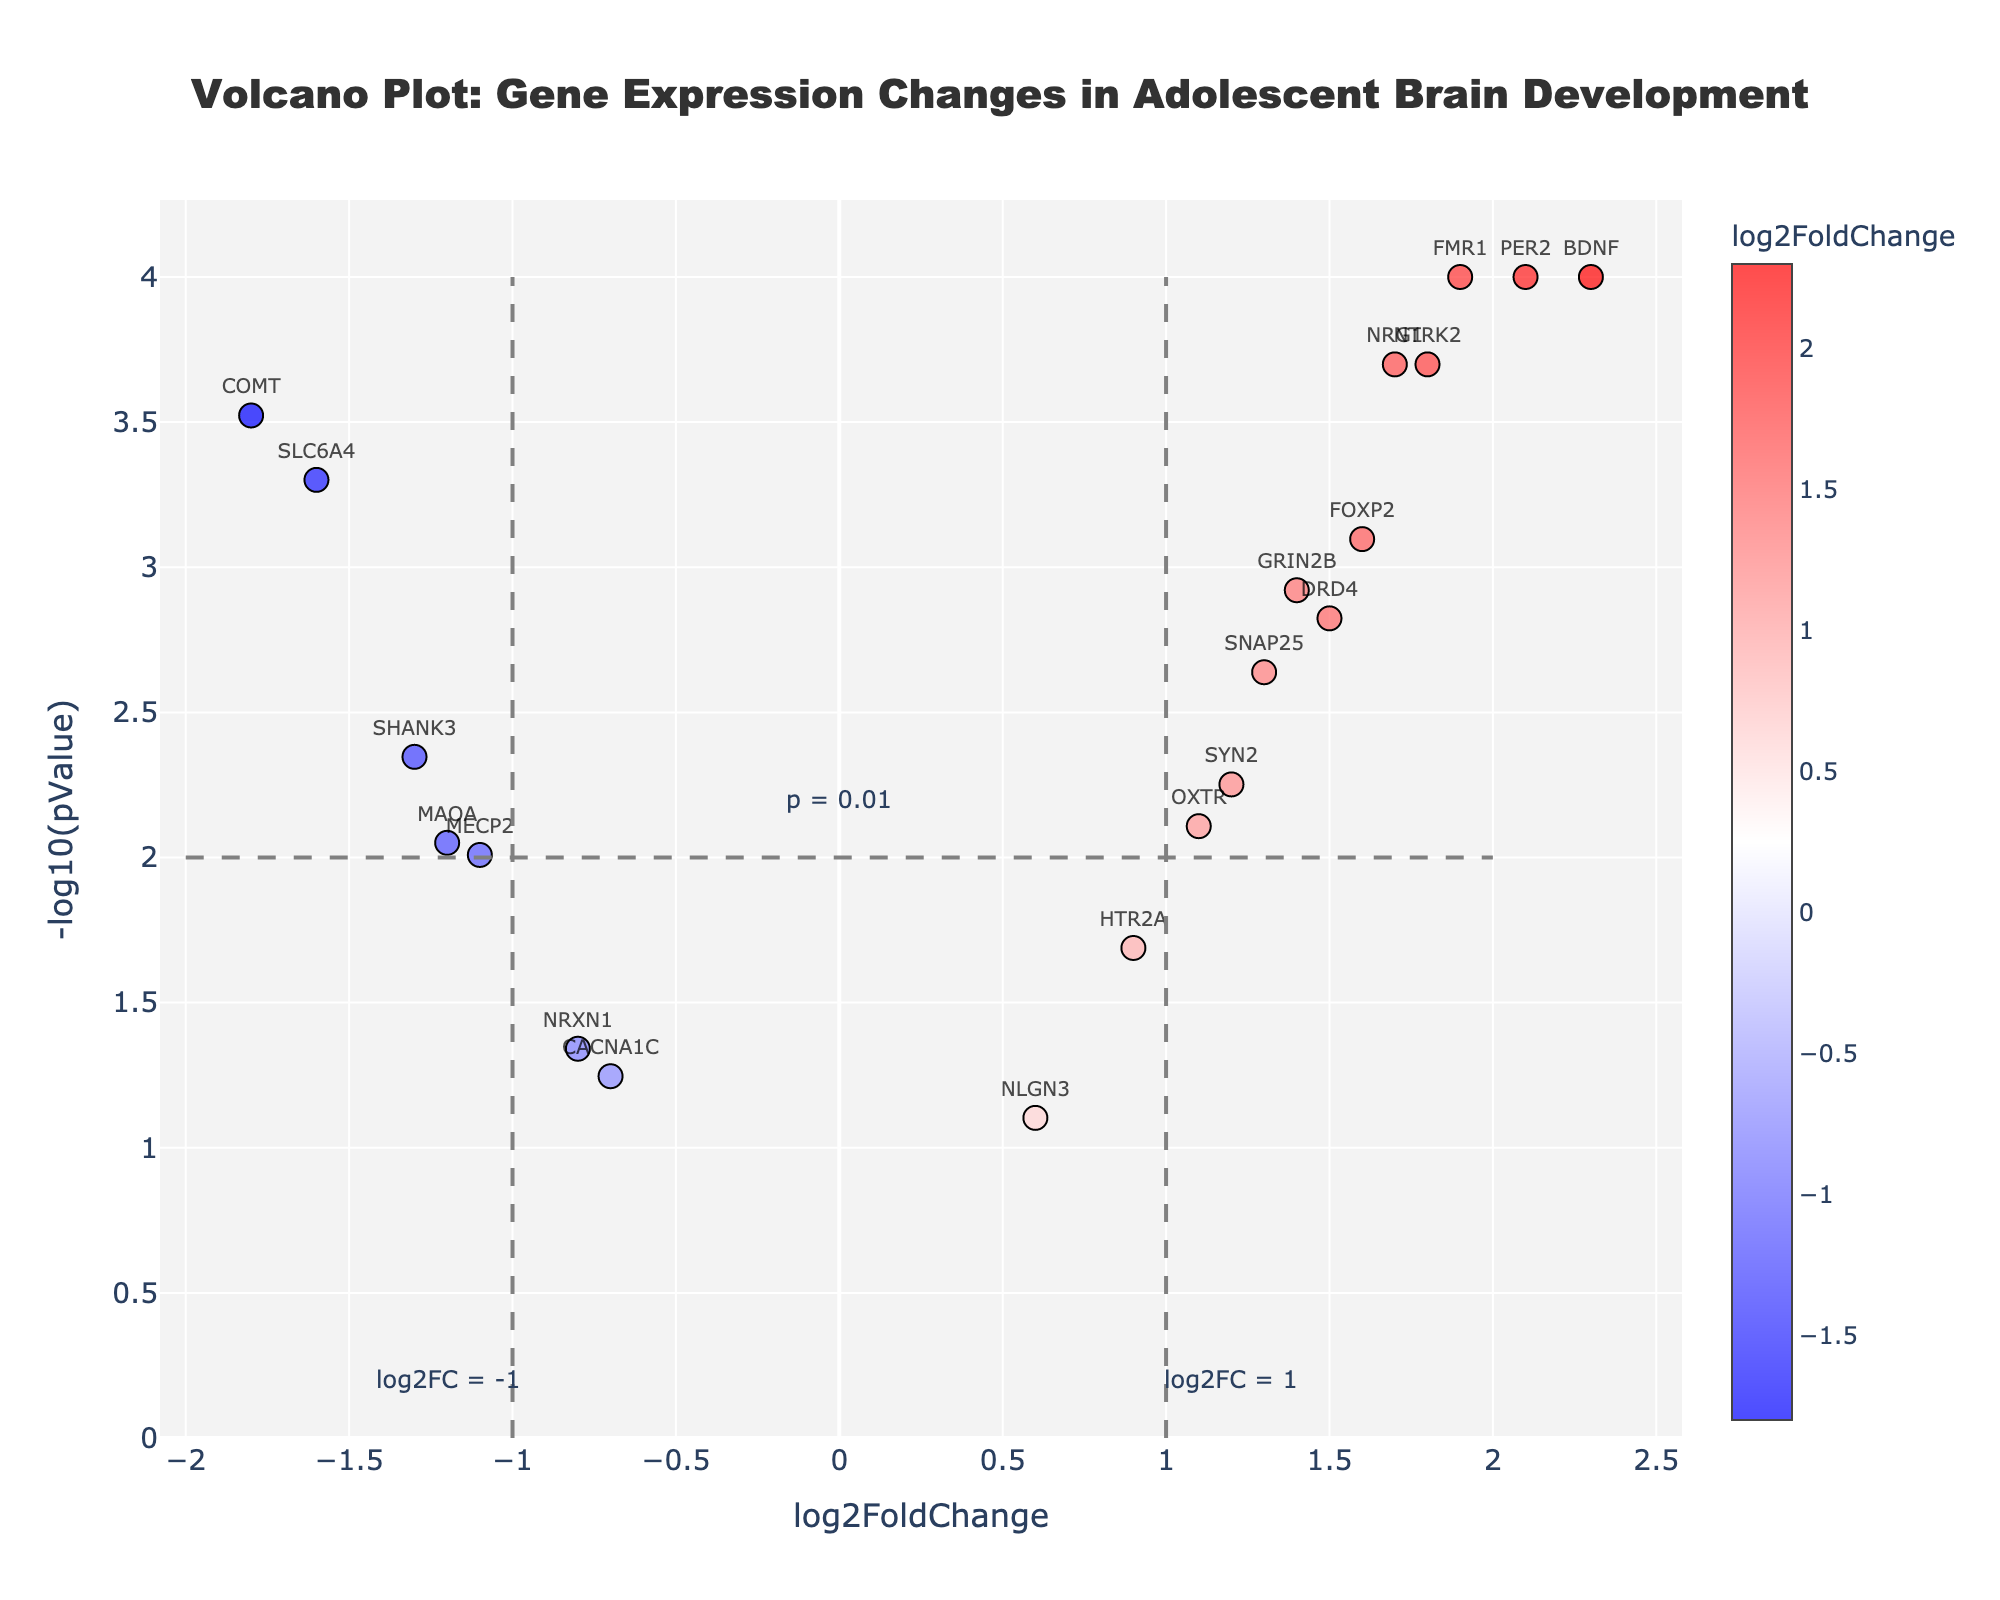what is the title of the plot? The title is provided at the top center of the figure which reads, "Volcano Plot: Gene Expression Changes in Adolescent Brain Development".
Answer: Volcano Plot: Gene Expression Changes in Adolescent Brain Development how many data points are there in the plot? Each gene represents a single data point. By counting the number of genes listed, we find there are 20 data points.
Answer: 20 what is the significance threshold for p-values? There is an annotation at y = 2.2 that indicates the significance threshold, "p = 0.01". This means any point above this line has a p-value less than 0.01.
Answer: p = 0.01 which gene has the highest log2FoldChange? By locating the point farthest to the right on the x-axis, we find the gene with the highest log2FoldChange is BDNF at 2.3.
Answer: BDNF which gene has the lowest p-value? The y-axis is scaled as -log10(pValue), so the highest point on the y-axis indicates the lowest p-value. The gene with the highest position is BDNF, PER2, and FMR1 all at -log10(pValue) around 4.
Answer: BDNF, PER2, FMR1 which genes have a log2FoldChange greater than 2? By identifying the points farther right than the x = 2 threshold, the genes are BDNF (2.3) and PER2 (2.1).
Answer: BDNF, PER2 which gene has the smallest log2FoldChange? The point farthest to the left on the x-axis indicates the smallest log2FoldChange, which is COMT at -1.8.
Answer: COMT how many genes have a log2FoldChange between -1 and 1? To find this, count the number of genes that fall between x = -1 and x = 1. Counting these, there are DRD4, HTR2A, NRXN1, CACNA1C, and NLGN3, so 5 genes in total.
Answer: 5 which genes are significantly upregulated (log2FoldChange > 1 and p < 0.01)? To identify this, we look for points to the right of x = 1 and above y = 2. These are BDNF, PER2, FMR1, NTRK2, and FOXP2.
Answer: BDNF, PER2, FMR1, NTRK2, FOXP2 which genes show significant downregulation (log2FoldChange < -1 and p < 0.01)? To find significantly downregulated genes, locate points to the left of x = -1 and above y = 2. These are COMT, SLC6A4, SHANK3.
Answer: COMT, SLC6A4, SHANK3 